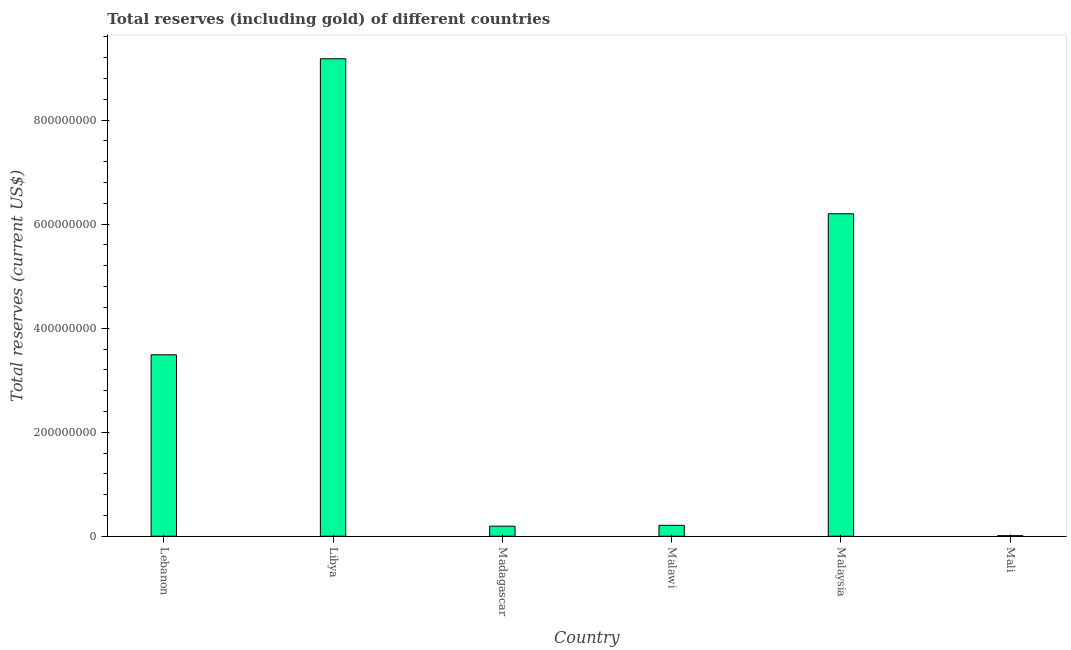What is the title of the graph?
Your answer should be very brief. Total reserves (including gold) of different countries. What is the label or title of the Y-axis?
Ensure brevity in your answer.  Total reserves (current US$). What is the total reserves (including gold) in Madagascar?
Your answer should be compact. 1.94e+07. Across all countries, what is the maximum total reserves (including gold)?
Give a very brief answer. 9.18e+08. Across all countries, what is the minimum total reserves (including gold)?
Offer a very short reply. 1.10e+06. In which country was the total reserves (including gold) maximum?
Make the answer very short. Libya. In which country was the total reserves (including gold) minimum?
Provide a succinct answer. Mali. What is the sum of the total reserves (including gold)?
Provide a short and direct response. 1.93e+09. What is the difference between the total reserves (including gold) in Madagascar and Malaysia?
Your response must be concise. -6.01e+08. What is the average total reserves (including gold) per country?
Your answer should be compact. 3.21e+08. What is the median total reserves (including gold)?
Offer a very short reply. 1.85e+08. In how many countries, is the total reserves (including gold) greater than 840000000 US$?
Keep it short and to the point. 1. What is the ratio of the total reserves (including gold) in Malawi to that in Mali?
Your response must be concise. 19.1. Is the total reserves (including gold) in Malawi less than that in Malaysia?
Ensure brevity in your answer.  Yes. What is the difference between the highest and the second highest total reserves (including gold)?
Offer a terse response. 2.98e+08. Is the sum of the total reserves (including gold) in Malawi and Malaysia greater than the maximum total reserves (including gold) across all countries?
Keep it short and to the point. No. What is the difference between the highest and the lowest total reserves (including gold)?
Provide a short and direct response. 9.17e+08. In how many countries, is the total reserves (including gold) greater than the average total reserves (including gold) taken over all countries?
Keep it short and to the point. 3. How many bars are there?
Give a very brief answer. 6. Are the values on the major ticks of Y-axis written in scientific E-notation?
Give a very brief answer. No. What is the Total reserves (current US$) of Lebanon?
Provide a short and direct response. 3.49e+08. What is the Total reserves (current US$) in Libya?
Make the answer very short. 9.18e+08. What is the Total reserves (current US$) in Madagascar?
Offer a terse response. 1.94e+07. What is the Total reserves (current US$) in Malawi?
Offer a very short reply. 2.10e+07. What is the Total reserves (current US$) of Malaysia?
Your answer should be compact. 6.20e+08. What is the Total reserves (current US$) in Mali?
Offer a very short reply. 1.10e+06. What is the difference between the Total reserves (current US$) in Lebanon and Libya?
Your response must be concise. -5.69e+08. What is the difference between the Total reserves (current US$) in Lebanon and Madagascar?
Your response must be concise. 3.30e+08. What is the difference between the Total reserves (current US$) in Lebanon and Malawi?
Give a very brief answer. 3.28e+08. What is the difference between the Total reserves (current US$) in Lebanon and Malaysia?
Your answer should be compact. -2.71e+08. What is the difference between the Total reserves (current US$) in Lebanon and Mali?
Keep it short and to the point. 3.48e+08. What is the difference between the Total reserves (current US$) in Libya and Madagascar?
Give a very brief answer. 8.99e+08. What is the difference between the Total reserves (current US$) in Libya and Malawi?
Your answer should be compact. 8.97e+08. What is the difference between the Total reserves (current US$) in Libya and Malaysia?
Your answer should be very brief. 2.98e+08. What is the difference between the Total reserves (current US$) in Libya and Mali?
Provide a succinct answer. 9.17e+08. What is the difference between the Total reserves (current US$) in Madagascar and Malawi?
Ensure brevity in your answer.  -1.63e+06. What is the difference between the Total reserves (current US$) in Madagascar and Malaysia?
Your answer should be very brief. -6.01e+08. What is the difference between the Total reserves (current US$) in Madagascar and Mali?
Your response must be concise. 1.83e+07. What is the difference between the Total reserves (current US$) in Malawi and Malaysia?
Give a very brief answer. -5.99e+08. What is the difference between the Total reserves (current US$) in Malawi and Mali?
Ensure brevity in your answer.  1.99e+07. What is the difference between the Total reserves (current US$) in Malaysia and Mali?
Make the answer very short. 6.19e+08. What is the ratio of the Total reserves (current US$) in Lebanon to that in Libya?
Provide a succinct answer. 0.38. What is the ratio of the Total reserves (current US$) in Lebanon to that in Madagascar?
Your answer should be very brief. 18. What is the ratio of the Total reserves (current US$) in Lebanon to that in Malawi?
Your answer should be compact. 16.61. What is the ratio of the Total reserves (current US$) in Lebanon to that in Malaysia?
Make the answer very short. 0.56. What is the ratio of the Total reserves (current US$) in Lebanon to that in Mali?
Your answer should be compact. 317.18. What is the ratio of the Total reserves (current US$) in Libya to that in Madagascar?
Provide a succinct answer. 47.37. What is the ratio of the Total reserves (current US$) in Libya to that in Malawi?
Keep it short and to the point. 43.7. What is the ratio of the Total reserves (current US$) in Libya to that in Malaysia?
Provide a short and direct response. 1.48. What is the ratio of the Total reserves (current US$) in Libya to that in Mali?
Offer a very short reply. 834.6. What is the ratio of the Total reserves (current US$) in Madagascar to that in Malawi?
Give a very brief answer. 0.92. What is the ratio of the Total reserves (current US$) in Madagascar to that in Malaysia?
Give a very brief answer. 0.03. What is the ratio of the Total reserves (current US$) in Madagascar to that in Mali?
Offer a terse response. 17.62. What is the ratio of the Total reserves (current US$) in Malawi to that in Malaysia?
Offer a terse response. 0.03. What is the ratio of the Total reserves (current US$) in Malaysia to that in Mali?
Your answer should be very brief. 563.62. 